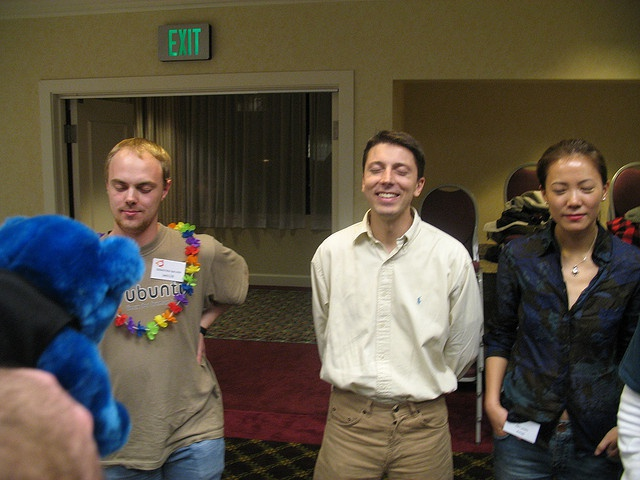Describe the objects in this image and their specific colors. I can see people in darkgreen, beige, gray, and darkgray tones, people in darkgreen, black, gray, and maroon tones, people in darkgreen, gray, and tan tones, teddy bear in darkgreen, navy, black, blue, and darkblue tones, and people in darkgreen, gray, tan, lightpink, and salmon tones in this image. 